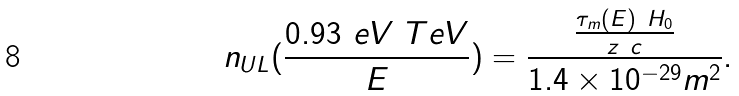<formula> <loc_0><loc_0><loc_500><loc_500>n _ { U L } ( \frac { 0 . 9 3 \ e V \ T e V } { E } ) = \frac { \frac { \tau _ { m } ( E ) \ H _ { 0 } } { z \ c } } { 1 . 4 \times 1 0 ^ { - 2 9 } m ^ { 2 } } .</formula> 